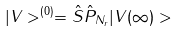<formula> <loc_0><loc_0><loc_500><loc_500>| V > ^ { ( 0 ) } = \hat { S } \hat { P } _ { N _ { r } } | V ( \infty ) ></formula> 